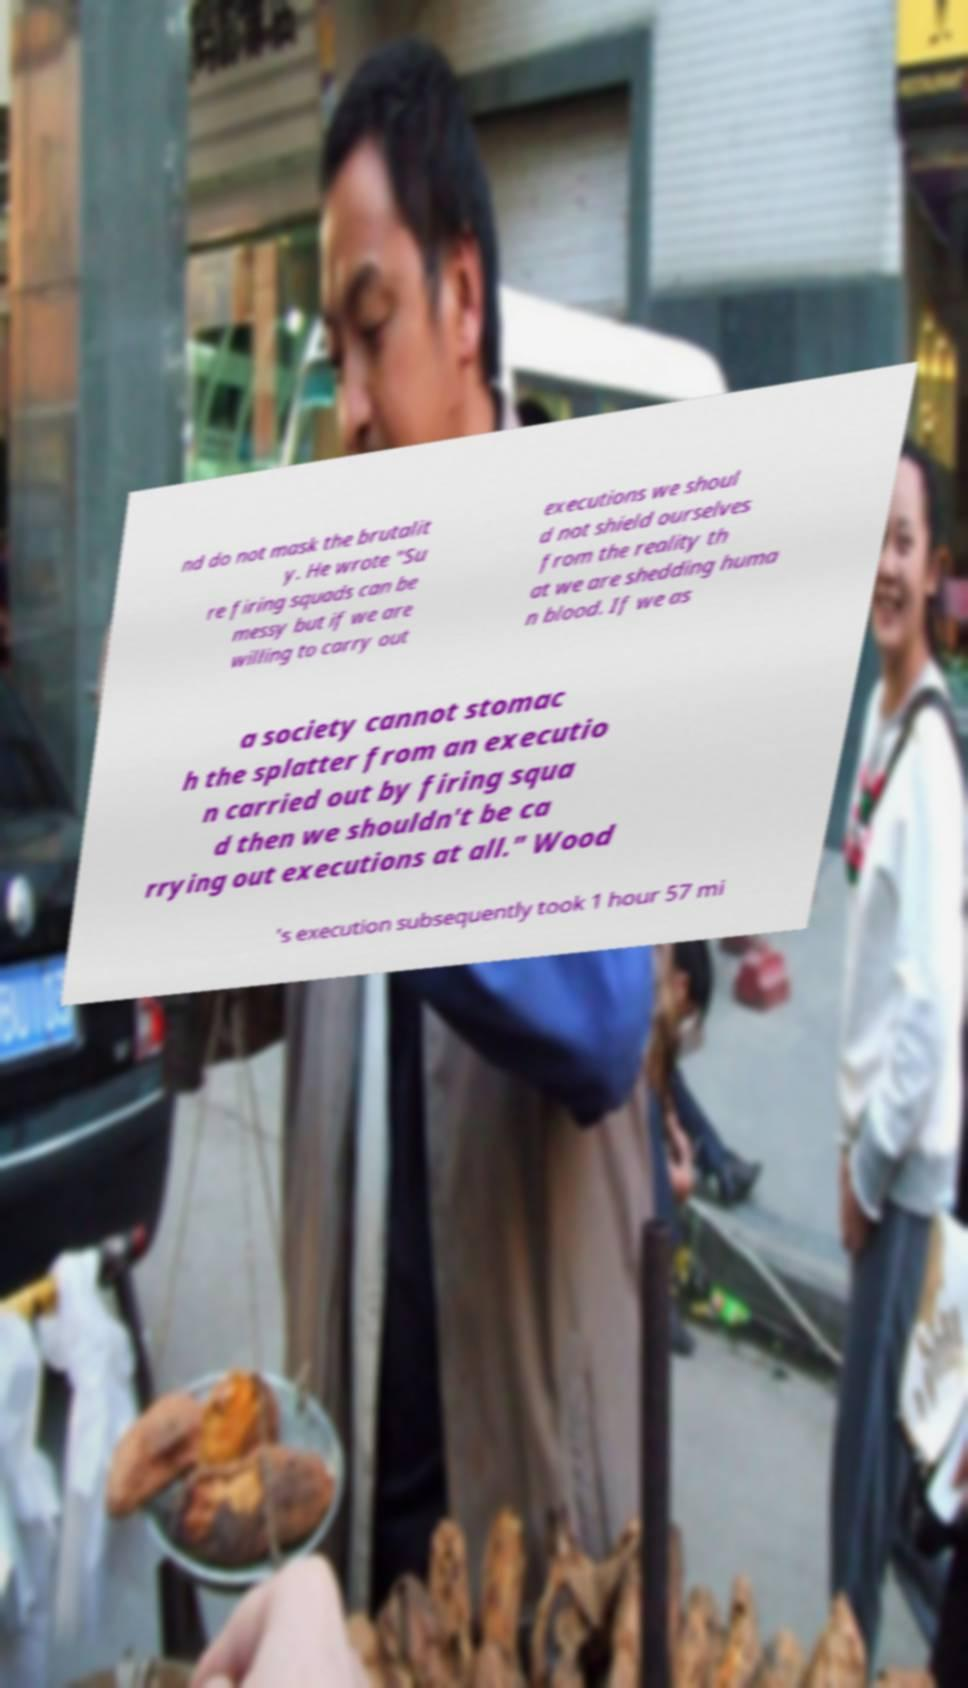Can you read and provide the text displayed in the image?This photo seems to have some interesting text. Can you extract and type it out for me? nd do not mask the brutalit y. He wrote "Su re firing squads can be messy but if we are willing to carry out executions we shoul d not shield ourselves from the reality th at we are shedding huma n blood. If we as a society cannot stomac h the splatter from an executio n carried out by firing squa d then we shouldn't be ca rrying out executions at all." Wood 's execution subsequently took 1 hour 57 mi 